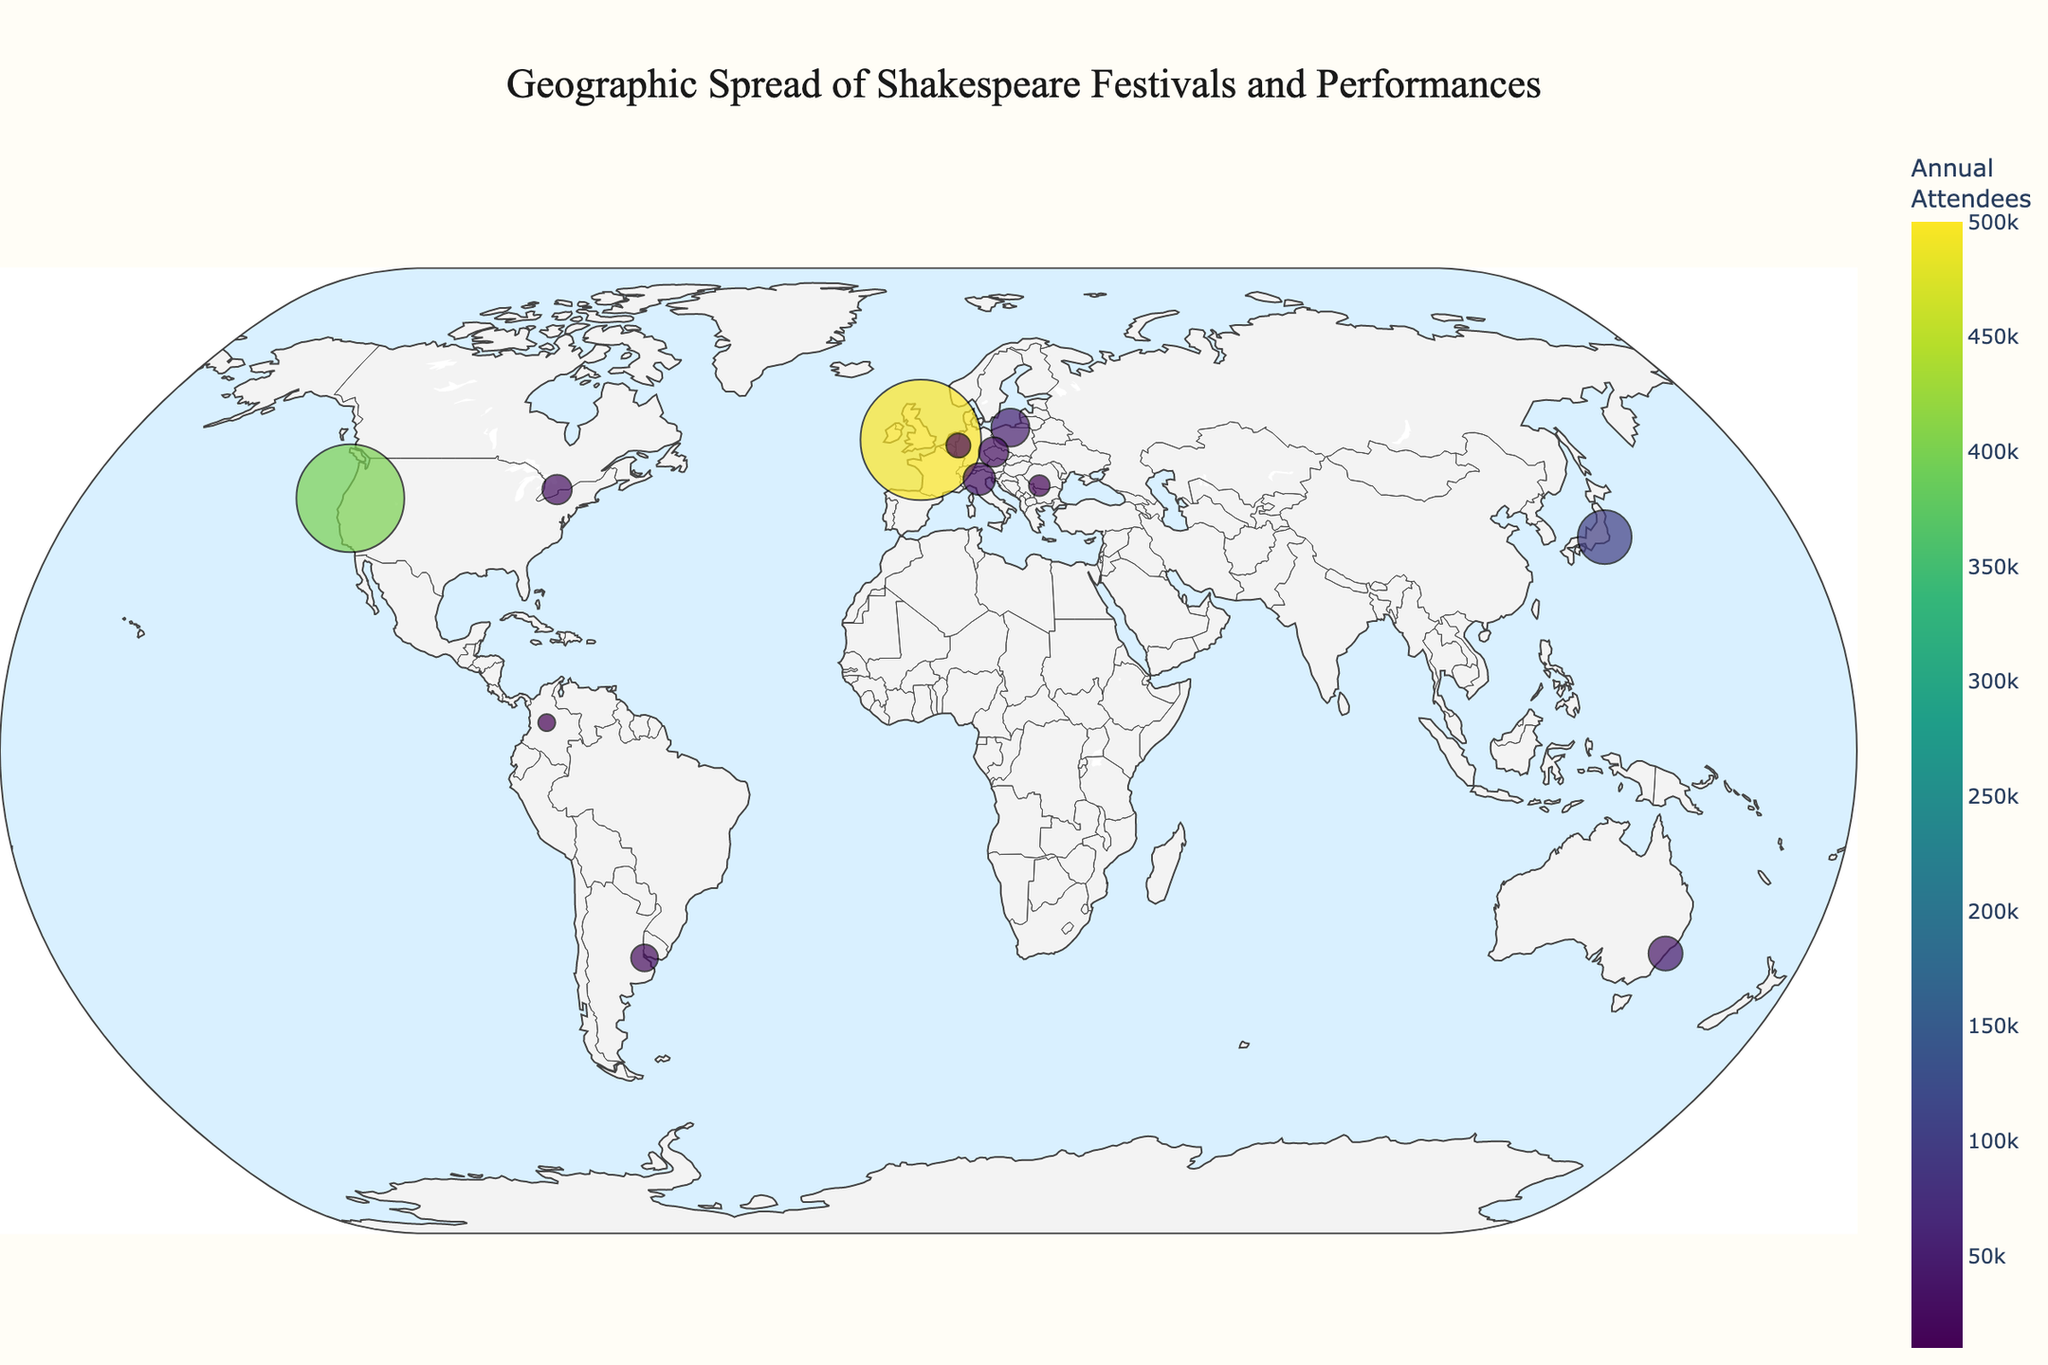Which festival has the highest number of annual attendees? The figure includes the number of annual attendees for each festival. By examining the values, we can see that the Royal Shakespeare Company in Stratford-upon-Avon, UK, has the highest attendance with 500,000 attendees annually.
Answer: Royal Shakespeare Company What is the title of the map? The title of the map is prominently displayed at the top of the figure. It reads "Geographic Spread of Shakespeare Festivals and Performances."
Answer: Geographic Spread of Shakespeare Festivals and Performances Which city in Japan hosts a Shakespeare festival? By looking at the locations marked on the map and the corresponding festival names, we can find that Tokyo, Japan, hosts the Tokyo Globe Theatre.
Answer: Tokyo How many festivals have fewer than 30,000 annual attendees? By examining the markers and corresponding attendee numbers on the map, we can identify that the following festivals have fewer than 30,000 attendees: International Shakespeare Festival in Craiova (15,000), Shakespeare Festival im Globe Neuss (20,000), and Festival Shakespeare Bogotá (10,000). Therefore, there are 3 festivals with fewer than 30,000 attendees.
Answer: 3 Which country in South America is shown to have a Shakespeare festival, and what is the name of the festival? By examining the geographic spread on the map, the only South American country with a Shakespeare festival is Argentina. The name of the festival is Shakespeare in Buenos Aires.
Answer: Argentina, Shakespeare in Buenos Aires How does the annual attendance of the Oregon Shakespeare Festival compare to that of the Tokyo Globe Theatre? From the data on the map, the Oregon Shakespeare Festival has 400,000 annual attendees, whereas the Tokyo Globe Theatre has 100,000 annual attendees. Therefore, the Oregon Shakespeare Festival has 300,000 more attendees than the Tokyo Globe Theatre.
Answer: Oregon Shakespeare Festival has 300,000 more attendees Which European city hosts the International Shakespeare Festival? According to the map, the International Shakespeare Festival takes place in Craiova, Romania.
Answer: Craiova What is the average annual attendance of the three festivals with the largest crowds? The three festivals with the largest crowds are the Royal Shakespeare Company (500,000), Oregon Shakespeare Festival (400,000), and Tokyo Globe Theatre (100,000). The average can be calculated by (500,000 + 400,000 + 100,000) / 3, which equals 1,000,000 / 3, or approximately 333,333.
Answer: 333,333 How many Shakespeare festivals are located in Europe? By examining the markers on the map and their corresponding locations, we see that there are five festivals in Europe: Royal Shakespeare Company (UK), Gdańsk Shakespeare Festival (Poland), Prague Shakespeare Company (Czech Republic), Shakespeare Festival im Globe Neuss (Germany), and Shakespeare in Verona (Italy).
Answer: 5 